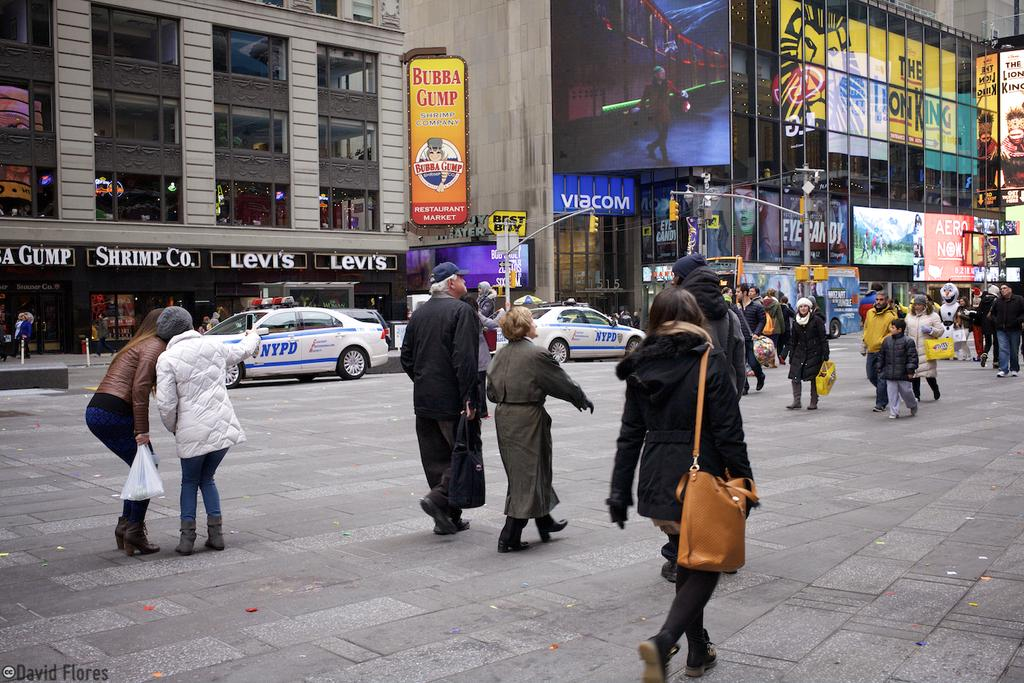What can be seen on the road in the image? There are persons standing on the road and vehicles on the road. What structures are present in the image? There are traffic poles, boards, and screens in the image. What type of buildings can be seen in the image? There are buildings visible in the image. How many horses are present in the image? There are no horses present in the image. What type of laborer can be seen working on the buildings in the image? There is no laborer present in the image. 